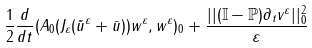Convert formula to latex. <formula><loc_0><loc_0><loc_500><loc_500>\frac { 1 } { 2 } \frac { d } { d t } ( A _ { 0 } ( J _ { \varepsilon } ( \tilde { u } ^ { \varepsilon } + \bar { u } ) ) w ^ { \varepsilon } , w ^ { \varepsilon } ) _ { 0 } + \frac { | | ( \mathbb { I } - \mathbb { P } ) \partial _ { t } v ^ { \varepsilon } | | _ { 0 } ^ { 2 } } { \varepsilon }</formula> 